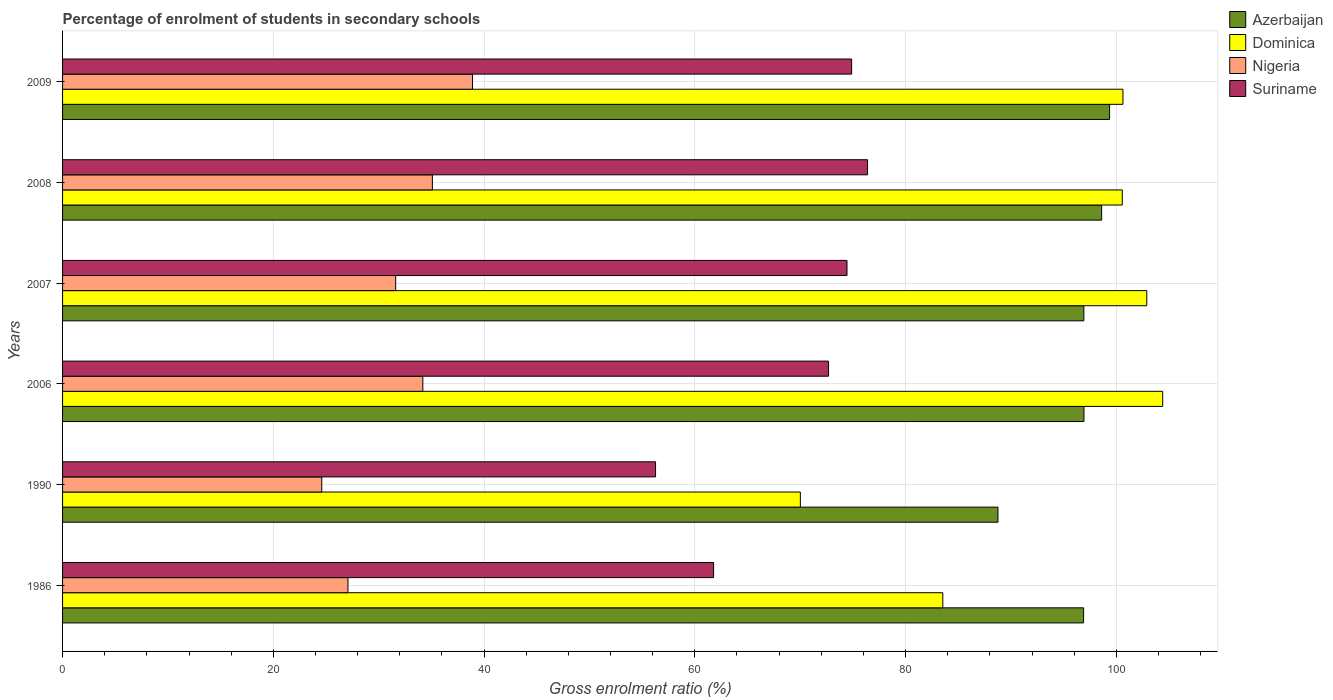How many groups of bars are there?
Offer a very short reply. 6. Are the number of bars on each tick of the Y-axis equal?
Offer a very short reply. Yes. How many bars are there on the 3rd tick from the top?
Offer a terse response. 4. What is the label of the 2nd group of bars from the top?
Your response must be concise. 2008. In how many cases, is the number of bars for a given year not equal to the number of legend labels?
Your answer should be very brief. 0. What is the percentage of students enrolled in secondary schools in Nigeria in 1986?
Provide a succinct answer. 27.08. Across all years, what is the maximum percentage of students enrolled in secondary schools in Azerbaijan?
Provide a short and direct response. 99.36. Across all years, what is the minimum percentage of students enrolled in secondary schools in Suriname?
Give a very brief answer. 56.27. What is the total percentage of students enrolled in secondary schools in Dominica in the graph?
Offer a very short reply. 562.02. What is the difference between the percentage of students enrolled in secondary schools in Suriname in 2008 and that in 2009?
Offer a very short reply. 1.51. What is the difference between the percentage of students enrolled in secondary schools in Azerbaijan in 1990 and the percentage of students enrolled in secondary schools in Nigeria in 2007?
Your response must be concise. 57.15. What is the average percentage of students enrolled in secondary schools in Azerbaijan per year?
Your answer should be very brief. 96.24. In the year 2009, what is the difference between the percentage of students enrolled in secondary schools in Nigeria and percentage of students enrolled in secondary schools in Suriname?
Provide a succinct answer. -35.98. What is the ratio of the percentage of students enrolled in secondary schools in Nigeria in 2007 to that in 2008?
Ensure brevity in your answer.  0.9. Is the percentage of students enrolled in secondary schools in Azerbaijan in 1990 less than that in 2007?
Your answer should be very brief. Yes. Is the difference between the percentage of students enrolled in secondary schools in Nigeria in 2006 and 2007 greater than the difference between the percentage of students enrolled in secondary schools in Suriname in 2006 and 2007?
Your response must be concise. Yes. What is the difference between the highest and the second highest percentage of students enrolled in secondary schools in Azerbaijan?
Give a very brief answer. 0.75. What is the difference between the highest and the lowest percentage of students enrolled in secondary schools in Azerbaijan?
Give a very brief answer. 10.59. In how many years, is the percentage of students enrolled in secondary schools in Nigeria greater than the average percentage of students enrolled in secondary schools in Nigeria taken over all years?
Your response must be concise. 3. What does the 3rd bar from the top in 2008 represents?
Offer a very short reply. Dominica. What does the 3rd bar from the bottom in 2006 represents?
Your answer should be compact. Nigeria. Is it the case that in every year, the sum of the percentage of students enrolled in secondary schools in Azerbaijan and percentage of students enrolled in secondary schools in Nigeria is greater than the percentage of students enrolled in secondary schools in Dominica?
Your answer should be compact. Yes. How many bars are there?
Provide a short and direct response. 24. Are all the bars in the graph horizontal?
Provide a short and direct response. Yes. How many years are there in the graph?
Ensure brevity in your answer.  6. What is the difference between two consecutive major ticks on the X-axis?
Keep it short and to the point. 20. Does the graph contain any zero values?
Provide a short and direct response. No. Does the graph contain grids?
Give a very brief answer. Yes. What is the title of the graph?
Your answer should be compact. Percentage of enrolment of students in secondary schools. Does "Chile" appear as one of the legend labels in the graph?
Offer a very short reply. No. What is the Gross enrolment ratio (%) in Azerbaijan in 1986?
Give a very brief answer. 96.89. What is the Gross enrolment ratio (%) in Dominica in 1986?
Provide a short and direct response. 83.53. What is the Gross enrolment ratio (%) in Nigeria in 1986?
Offer a terse response. 27.08. What is the Gross enrolment ratio (%) in Suriname in 1986?
Provide a short and direct response. 61.78. What is the Gross enrolment ratio (%) of Azerbaijan in 1990?
Keep it short and to the point. 88.76. What is the Gross enrolment ratio (%) in Dominica in 1990?
Your answer should be compact. 70.01. What is the Gross enrolment ratio (%) of Nigeria in 1990?
Offer a very short reply. 24.6. What is the Gross enrolment ratio (%) of Suriname in 1990?
Your answer should be very brief. 56.27. What is the Gross enrolment ratio (%) of Azerbaijan in 2006?
Your response must be concise. 96.93. What is the Gross enrolment ratio (%) in Dominica in 2006?
Your answer should be very brief. 104.4. What is the Gross enrolment ratio (%) in Nigeria in 2006?
Offer a very short reply. 34.19. What is the Gross enrolment ratio (%) of Suriname in 2006?
Provide a short and direct response. 72.69. What is the Gross enrolment ratio (%) in Azerbaijan in 2007?
Keep it short and to the point. 96.92. What is the Gross enrolment ratio (%) of Dominica in 2007?
Ensure brevity in your answer.  102.89. What is the Gross enrolment ratio (%) of Nigeria in 2007?
Provide a short and direct response. 31.61. What is the Gross enrolment ratio (%) in Suriname in 2007?
Your response must be concise. 74.44. What is the Gross enrolment ratio (%) in Azerbaijan in 2008?
Offer a very short reply. 98.61. What is the Gross enrolment ratio (%) in Dominica in 2008?
Give a very brief answer. 100.56. What is the Gross enrolment ratio (%) in Nigeria in 2008?
Provide a succinct answer. 35.09. What is the Gross enrolment ratio (%) of Suriname in 2008?
Provide a short and direct response. 76.39. What is the Gross enrolment ratio (%) of Azerbaijan in 2009?
Your response must be concise. 99.36. What is the Gross enrolment ratio (%) in Dominica in 2009?
Make the answer very short. 100.63. What is the Gross enrolment ratio (%) in Nigeria in 2009?
Ensure brevity in your answer.  38.9. What is the Gross enrolment ratio (%) of Suriname in 2009?
Give a very brief answer. 74.88. Across all years, what is the maximum Gross enrolment ratio (%) in Azerbaijan?
Offer a very short reply. 99.36. Across all years, what is the maximum Gross enrolment ratio (%) of Dominica?
Provide a succinct answer. 104.4. Across all years, what is the maximum Gross enrolment ratio (%) in Nigeria?
Your answer should be compact. 38.9. Across all years, what is the maximum Gross enrolment ratio (%) in Suriname?
Offer a very short reply. 76.39. Across all years, what is the minimum Gross enrolment ratio (%) in Azerbaijan?
Make the answer very short. 88.76. Across all years, what is the minimum Gross enrolment ratio (%) in Dominica?
Your answer should be very brief. 70.01. Across all years, what is the minimum Gross enrolment ratio (%) in Nigeria?
Give a very brief answer. 24.6. Across all years, what is the minimum Gross enrolment ratio (%) of Suriname?
Offer a very short reply. 56.27. What is the total Gross enrolment ratio (%) of Azerbaijan in the graph?
Keep it short and to the point. 577.46. What is the total Gross enrolment ratio (%) in Dominica in the graph?
Ensure brevity in your answer.  562.02. What is the total Gross enrolment ratio (%) of Nigeria in the graph?
Provide a short and direct response. 191.47. What is the total Gross enrolment ratio (%) in Suriname in the graph?
Give a very brief answer. 416.45. What is the difference between the Gross enrolment ratio (%) of Azerbaijan in 1986 and that in 1990?
Your response must be concise. 8.13. What is the difference between the Gross enrolment ratio (%) in Dominica in 1986 and that in 1990?
Provide a succinct answer. 13.52. What is the difference between the Gross enrolment ratio (%) of Nigeria in 1986 and that in 1990?
Provide a short and direct response. 2.49. What is the difference between the Gross enrolment ratio (%) of Suriname in 1986 and that in 1990?
Offer a terse response. 5.51. What is the difference between the Gross enrolment ratio (%) of Azerbaijan in 1986 and that in 2006?
Keep it short and to the point. -0.03. What is the difference between the Gross enrolment ratio (%) of Dominica in 1986 and that in 2006?
Keep it short and to the point. -20.87. What is the difference between the Gross enrolment ratio (%) in Nigeria in 1986 and that in 2006?
Provide a short and direct response. -7.11. What is the difference between the Gross enrolment ratio (%) of Suriname in 1986 and that in 2006?
Offer a terse response. -10.91. What is the difference between the Gross enrolment ratio (%) of Azerbaijan in 1986 and that in 2007?
Give a very brief answer. -0.02. What is the difference between the Gross enrolment ratio (%) in Dominica in 1986 and that in 2007?
Offer a terse response. -19.36. What is the difference between the Gross enrolment ratio (%) in Nigeria in 1986 and that in 2007?
Give a very brief answer. -4.53. What is the difference between the Gross enrolment ratio (%) in Suriname in 1986 and that in 2007?
Ensure brevity in your answer.  -12.66. What is the difference between the Gross enrolment ratio (%) of Azerbaijan in 1986 and that in 2008?
Offer a very short reply. -1.71. What is the difference between the Gross enrolment ratio (%) of Dominica in 1986 and that in 2008?
Ensure brevity in your answer.  -17.03. What is the difference between the Gross enrolment ratio (%) of Nigeria in 1986 and that in 2008?
Your response must be concise. -8.01. What is the difference between the Gross enrolment ratio (%) of Suriname in 1986 and that in 2008?
Provide a short and direct response. -14.61. What is the difference between the Gross enrolment ratio (%) in Azerbaijan in 1986 and that in 2009?
Provide a short and direct response. -2.46. What is the difference between the Gross enrolment ratio (%) of Dominica in 1986 and that in 2009?
Your answer should be compact. -17.1. What is the difference between the Gross enrolment ratio (%) of Nigeria in 1986 and that in 2009?
Make the answer very short. -11.82. What is the difference between the Gross enrolment ratio (%) in Suriname in 1986 and that in 2009?
Your response must be concise. -13.1. What is the difference between the Gross enrolment ratio (%) in Azerbaijan in 1990 and that in 2006?
Give a very brief answer. -8.16. What is the difference between the Gross enrolment ratio (%) of Dominica in 1990 and that in 2006?
Make the answer very short. -34.39. What is the difference between the Gross enrolment ratio (%) of Nigeria in 1990 and that in 2006?
Keep it short and to the point. -9.59. What is the difference between the Gross enrolment ratio (%) in Suriname in 1990 and that in 2006?
Your answer should be compact. -16.42. What is the difference between the Gross enrolment ratio (%) of Azerbaijan in 1990 and that in 2007?
Give a very brief answer. -8.15. What is the difference between the Gross enrolment ratio (%) in Dominica in 1990 and that in 2007?
Make the answer very short. -32.87. What is the difference between the Gross enrolment ratio (%) in Nigeria in 1990 and that in 2007?
Your answer should be compact. -7.01. What is the difference between the Gross enrolment ratio (%) in Suriname in 1990 and that in 2007?
Make the answer very short. -18.17. What is the difference between the Gross enrolment ratio (%) in Azerbaijan in 1990 and that in 2008?
Provide a short and direct response. -9.84. What is the difference between the Gross enrolment ratio (%) in Dominica in 1990 and that in 2008?
Your response must be concise. -30.55. What is the difference between the Gross enrolment ratio (%) of Nigeria in 1990 and that in 2008?
Give a very brief answer. -10.5. What is the difference between the Gross enrolment ratio (%) of Suriname in 1990 and that in 2008?
Give a very brief answer. -20.12. What is the difference between the Gross enrolment ratio (%) in Azerbaijan in 1990 and that in 2009?
Offer a very short reply. -10.59. What is the difference between the Gross enrolment ratio (%) of Dominica in 1990 and that in 2009?
Keep it short and to the point. -30.61. What is the difference between the Gross enrolment ratio (%) in Nigeria in 1990 and that in 2009?
Give a very brief answer. -14.31. What is the difference between the Gross enrolment ratio (%) in Suriname in 1990 and that in 2009?
Ensure brevity in your answer.  -18.61. What is the difference between the Gross enrolment ratio (%) in Azerbaijan in 2006 and that in 2007?
Keep it short and to the point. 0.01. What is the difference between the Gross enrolment ratio (%) in Dominica in 2006 and that in 2007?
Your answer should be compact. 1.51. What is the difference between the Gross enrolment ratio (%) in Nigeria in 2006 and that in 2007?
Provide a short and direct response. 2.58. What is the difference between the Gross enrolment ratio (%) in Suriname in 2006 and that in 2007?
Your response must be concise. -1.75. What is the difference between the Gross enrolment ratio (%) of Azerbaijan in 2006 and that in 2008?
Your response must be concise. -1.68. What is the difference between the Gross enrolment ratio (%) in Dominica in 2006 and that in 2008?
Provide a short and direct response. 3.84. What is the difference between the Gross enrolment ratio (%) of Nigeria in 2006 and that in 2008?
Make the answer very short. -0.91. What is the difference between the Gross enrolment ratio (%) in Suriname in 2006 and that in 2008?
Provide a short and direct response. -3.7. What is the difference between the Gross enrolment ratio (%) of Azerbaijan in 2006 and that in 2009?
Keep it short and to the point. -2.43. What is the difference between the Gross enrolment ratio (%) in Dominica in 2006 and that in 2009?
Provide a succinct answer. 3.77. What is the difference between the Gross enrolment ratio (%) in Nigeria in 2006 and that in 2009?
Keep it short and to the point. -4.71. What is the difference between the Gross enrolment ratio (%) in Suriname in 2006 and that in 2009?
Your answer should be compact. -2.19. What is the difference between the Gross enrolment ratio (%) of Azerbaijan in 2007 and that in 2008?
Your response must be concise. -1.69. What is the difference between the Gross enrolment ratio (%) in Dominica in 2007 and that in 2008?
Offer a very short reply. 2.32. What is the difference between the Gross enrolment ratio (%) in Nigeria in 2007 and that in 2008?
Provide a succinct answer. -3.48. What is the difference between the Gross enrolment ratio (%) of Suriname in 2007 and that in 2008?
Your response must be concise. -1.95. What is the difference between the Gross enrolment ratio (%) of Azerbaijan in 2007 and that in 2009?
Offer a terse response. -2.44. What is the difference between the Gross enrolment ratio (%) in Dominica in 2007 and that in 2009?
Offer a very short reply. 2.26. What is the difference between the Gross enrolment ratio (%) in Nigeria in 2007 and that in 2009?
Keep it short and to the point. -7.29. What is the difference between the Gross enrolment ratio (%) in Suriname in 2007 and that in 2009?
Offer a terse response. -0.44. What is the difference between the Gross enrolment ratio (%) in Azerbaijan in 2008 and that in 2009?
Offer a terse response. -0.75. What is the difference between the Gross enrolment ratio (%) in Dominica in 2008 and that in 2009?
Offer a very short reply. -0.06. What is the difference between the Gross enrolment ratio (%) in Nigeria in 2008 and that in 2009?
Provide a short and direct response. -3.81. What is the difference between the Gross enrolment ratio (%) in Suriname in 2008 and that in 2009?
Make the answer very short. 1.51. What is the difference between the Gross enrolment ratio (%) of Azerbaijan in 1986 and the Gross enrolment ratio (%) of Dominica in 1990?
Your answer should be very brief. 26.88. What is the difference between the Gross enrolment ratio (%) in Azerbaijan in 1986 and the Gross enrolment ratio (%) in Nigeria in 1990?
Provide a succinct answer. 72.3. What is the difference between the Gross enrolment ratio (%) in Azerbaijan in 1986 and the Gross enrolment ratio (%) in Suriname in 1990?
Your answer should be very brief. 40.62. What is the difference between the Gross enrolment ratio (%) in Dominica in 1986 and the Gross enrolment ratio (%) in Nigeria in 1990?
Keep it short and to the point. 58.94. What is the difference between the Gross enrolment ratio (%) in Dominica in 1986 and the Gross enrolment ratio (%) in Suriname in 1990?
Give a very brief answer. 27.26. What is the difference between the Gross enrolment ratio (%) of Nigeria in 1986 and the Gross enrolment ratio (%) of Suriname in 1990?
Your answer should be compact. -29.19. What is the difference between the Gross enrolment ratio (%) in Azerbaijan in 1986 and the Gross enrolment ratio (%) in Dominica in 2006?
Your answer should be compact. -7.51. What is the difference between the Gross enrolment ratio (%) in Azerbaijan in 1986 and the Gross enrolment ratio (%) in Nigeria in 2006?
Give a very brief answer. 62.71. What is the difference between the Gross enrolment ratio (%) of Azerbaijan in 1986 and the Gross enrolment ratio (%) of Suriname in 2006?
Keep it short and to the point. 24.2. What is the difference between the Gross enrolment ratio (%) in Dominica in 1986 and the Gross enrolment ratio (%) in Nigeria in 2006?
Offer a very short reply. 49.34. What is the difference between the Gross enrolment ratio (%) of Dominica in 1986 and the Gross enrolment ratio (%) of Suriname in 2006?
Ensure brevity in your answer.  10.84. What is the difference between the Gross enrolment ratio (%) of Nigeria in 1986 and the Gross enrolment ratio (%) of Suriname in 2006?
Provide a succinct answer. -45.61. What is the difference between the Gross enrolment ratio (%) in Azerbaijan in 1986 and the Gross enrolment ratio (%) in Dominica in 2007?
Provide a succinct answer. -5.99. What is the difference between the Gross enrolment ratio (%) in Azerbaijan in 1986 and the Gross enrolment ratio (%) in Nigeria in 2007?
Make the answer very short. 65.28. What is the difference between the Gross enrolment ratio (%) of Azerbaijan in 1986 and the Gross enrolment ratio (%) of Suriname in 2007?
Offer a very short reply. 22.45. What is the difference between the Gross enrolment ratio (%) in Dominica in 1986 and the Gross enrolment ratio (%) in Nigeria in 2007?
Ensure brevity in your answer.  51.92. What is the difference between the Gross enrolment ratio (%) in Dominica in 1986 and the Gross enrolment ratio (%) in Suriname in 2007?
Provide a succinct answer. 9.09. What is the difference between the Gross enrolment ratio (%) in Nigeria in 1986 and the Gross enrolment ratio (%) in Suriname in 2007?
Your answer should be very brief. -47.36. What is the difference between the Gross enrolment ratio (%) of Azerbaijan in 1986 and the Gross enrolment ratio (%) of Dominica in 2008?
Your answer should be compact. -3.67. What is the difference between the Gross enrolment ratio (%) of Azerbaijan in 1986 and the Gross enrolment ratio (%) of Nigeria in 2008?
Your response must be concise. 61.8. What is the difference between the Gross enrolment ratio (%) of Azerbaijan in 1986 and the Gross enrolment ratio (%) of Suriname in 2008?
Provide a short and direct response. 20.5. What is the difference between the Gross enrolment ratio (%) of Dominica in 1986 and the Gross enrolment ratio (%) of Nigeria in 2008?
Keep it short and to the point. 48.44. What is the difference between the Gross enrolment ratio (%) in Dominica in 1986 and the Gross enrolment ratio (%) in Suriname in 2008?
Your answer should be very brief. 7.14. What is the difference between the Gross enrolment ratio (%) of Nigeria in 1986 and the Gross enrolment ratio (%) of Suriname in 2008?
Give a very brief answer. -49.31. What is the difference between the Gross enrolment ratio (%) in Azerbaijan in 1986 and the Gross enrolment ratio (%) in Dominica in 2009?
Your answer should be compact. -3.73. What is the difference between the Gross enrolment ratio (%) in Azerbaijan in 1986 and the Gross enrolment ratio (%) in Nigeria in 2009?
Offer a terse response. 57.99. What is the difference between the Gross enrolment ratio (%) in Azerbaijan in 1986 and the Gross enrolment ratio (%) in Suriname in 2009?
Provide a short and direct response. 22.01. What is the difference between the Gross enrolment ratio (%) of Dominica in 1986 and the Gross enrolment ratio (%) of Nigeria in 2009?
Provide a succinct answer. 44.63. What is the difference between the Gross enrolment ratio (%) of Dominica in 1986 and the Gross enrolment ratio (%) of Suriname in 2009?
Your response must be concise. 8.65. What is the difference between the Gross enrolment ratio (%) in Nigeria in 1986 and the Gross enrolment ratio (%) in Suriname in 2009?
Your answer should be very brief. -47.8. What is the difference between the Gross enrolment ratio (%) of Azerbaijan in 1990 and the Gross enrolment ratio (%) of Dominica in 2006?
Your answer should be compact. -15.63. What is the difference between the Gross enrolment ratio (%) in Azerbaijan in 1990 and the Gross enrolment ratio (%) in Nigeria in 2006?
Make the answer very short. 54.58. What is the difference between the Gross enrolment ratio (%) in Azerbaijan in 1990 and the Gross enrolment ratio (%) in Suriname in 2006?
Your response must be concise. 16.08. What is the difference between the Gross enrolment ratio (%) in Dominica in 1990 and the Gross enrolment ratio (%) in Nigeria in 2006?
Provide a short and direct response. 35.83. What is the difference between the Gross enrolment ratio (%) of Dominica in 1990 and the Gross enrolment ratio (%) of Suriname in 2006?
Make the answer very short. -2.67. What is the difference between the Gross enrolment ratio (%) of Nigeria in 1990 and the Gross enrolment ratio (%) of Suriname in 2006?
Your response must be concise. -48.09. What is the difference between the Gross enrolment ratio (%) in Azerbaijan in 1990 and the Gross enrolment ratio (%) in Dominica in 2007?
Provide a succinct answer. -14.12. What is the difference between the Gross enrolment ratio (%) in Azerbaijan in 1990 and the Gross enrolment ratio (%) in Nigeria in 2007?
Offer a terse response. 57.15. What is the difference between the Gross enrolment ratio (%) of Azerbaijan in 1990 and the Gross enrolment ratio (%) of Suriname in 2007?
Make the answer very short. 14.32. What is the difference between the Gross enrolment ratio (%) of Dominica in 1990 and the Gross enrolment ratio (%) of Nigeria in 2007?
Ensure brevity in your answer.  38.4. What is the difference between the Gross enrolment ratio (%) of Dominica in 1990 and the Gross enrolment ratio (%) of Suriname in 2007?
Offer a terse response. -4.43. What is the difference between the Gross enrolment ratio (%) of Nigeria in 1990 and the Gross enrolment ratio (%) of Suriname in 2007?
Your answer should be compact. -49.84. What is the difference between the Gross enrolment ratio (%) of Azerbaijan in 1990 and the Gross enrolment ratio (%) of Dominica in 2008?
Ensure brevity in your answer.  -11.8. What is the difference between the Gross enrolment ratio (%) of Azerbaijan in 1990 and the Gross enrolment ratio (%) of Nigeria in 2008?
Offer a very short reply. 53.67. What is the difference between the Gross enrolment ratio (%) of Azerbaijan in 1990 and the Gross enrolment ratio (%) of Suriname in 2008?
Your answer should be compact. 12.37. What is the difference between the Gross enrolment ratio (%) of Dominica in 1990 and the Gross enrolment ratio (%) of Nigeria in 2008?
Your response must be concise. 34.92. What is the difference between the Gross enrolment ratio (%) in Dominica in 1990 and the Gross enrolment ratio (%) in Suriname in 2008?
Your answer should be very brief. -6.38. What is the difference between the Gross enrolment ratio (%) of Nigeria in 1990 and the Gross enrolment ratio (%) of Suriname in 2008?
Your response must be concise. -51.8. What is the difference between the Gross enrolment ratio (%) in Azerbaijan in 1990 and the Gross enrolment ratio (%) in Dominica in 2009?
Provide a succinct answer. -11.86. What is the difference between the Gross enrolment ratio (%) in Azerbaijan in 1990 and the Gross enrolment ratio (%) in Nigeria in 2009?
Provide a short and direct response. 49.86. What is the difference between the Gross enrolment ratio (%) of Azerbaijan in 1990 and the Gross enrolment ratio (%) of Suriname in 2009?
Your answer should be compact. 13.88. What is the difference between the Gross enrolment ratio (%) of Dominica in 1990 and the Gross enrolment ratio (%) of Nigeria in 2009?
Your answer should be very brief. 31.11. What is the difference between the Gross enrolment ratio (%) of Dominica in 1990 and the Gross enrolment ratio (%) of Suriname in 2009?
Keep it short and to the point. -4.87. What is the difference between the Gross enrolment ratio (%) of Nigeria in 1990 and the Gross enrolment ratio (%) of Suriname in 2009?
Ensure brevity in your answer.  -50.28. What is the difference between the Gross enrolment ratio (%) in Azerbaijan in 2006 and the Gross enrolment ratio (%) in Dominica in 2007?
Ensure brevity in your answer.  -5.96. What is the difference between the Gross enrolment ratio (%) of Azerbaijan in 2006 and the Gross enrolment ratio (%) of Nigeria in 2007?
Ensure brevity in your answer.  65.32. What is the difference between the Gross enrolment ratio (%) of Azerbaijan in 2006 and the Gross enrolment ratio (%) of Suriname in 2007?
Your answer should be compact. 22.49. What is the difference between the Gross enrolment ratio (%) in Dominica in 2006 and the Gross enrolment ratio (%) in Nigeria in 2007?
Keep it short and to the point. 72.79. What is the difference between the Gross enrolment ratio (%) of Dominica in 2006 and the Gross enrolment ratio (%) of Suriname in 2007?
Ensure brevity in your answer.  29.96. What is the difference between the Gross enrolment ratio (%) of Nigeria in 2006 and the Gross enrolment ratio (%) of Suriname in 2007?
Make the answer very short. -40.25. What is the difference between the Gross enrolment ratio (%) in Azerbaijan in 2006 and the Gross enrolment ratio (%) in Dominica in 2008?
Make the answer very short. -3.64. What is the difference between the Gross enrolment ratio (%) in Azerbaijan in 2006 and the Gross enrolment ratio (%) in Nigeria in 2008?
Your answer should be compact. 61.83. What is the difference between the Gross enrolment ratio (%) in Azerbaijan in 2006 and the Gross enrolment ratio (%) in Suriname in 2008?
Provide a succinct answer. 20.53. What is the difference between the Gross enrolment ratio (%) in Dominica in 2006 and the Gross enrolment ratio (%) in Nigeria in 2008?
Your response must be concise. 69.31. What is the difference between the Gross enrolment ratio (%) of Dominica in 2006 and the Gross enrolment ratio (%) of Suriname in 2008?
Give a very brief answer. 28.01. What is the difference between the Gross enrolment ratio (%) in Nigeria in 2006 and the Gross enrolment ratio (%) in Suriname in 2008?
Provide a succinct answer. -42.2. What is the difference between the Gross enrolment ratio (%) in Azerbaijan in 2006 and the Gross enrolment ratio (%) in Dominica in 2009?
Provide a short and direct response. -3.7. What is the difference between the Gross enrolment ratio (%) of Azerbaijan in 2006 and the Gross enrolment ratio (%) of Nigeria in 2009?
Provide a short and direct response. 58.02. What is the difference between the Gross enrolment ratio (%) of Azerbaijan in 2006 and the Gross enrolment ratio (%) of Suriname in 2009?
Ensure brevity in your answer.  22.05. What is the difference between the Gross enrolment ratio (%) of Dominica in 2006 and the Gross enrolment ratio (%) of Nigeria in 2009?
Your answer should be compact. 65.5. What is the difference between the Gross enrolment ratio (%) in Dominica in 2006 and the Gross enrolment ratio (%) in Suriname in 2009?
Your response must be concise. 29.52. What is the difference between the Gross enrolment ratio (%) of Nigeria in 2006 and the Gross enrolment ratio (%) of Suriname in 2009?
Keep it short and to the point. -40.69. What is the difference between the Gross enrolment ratio (%) in Azerbaijan in 2007 and the Gross enrolment ratio (%) in Dominica in 2008?
Offer a terse response. -3.65. What is the difference between the Gross enrolment ratio (%) in Azerbaijan in 2007 and the Gross enrolment ratio (%) in Nigeria in 2008?
Offer a very short reply. 61.82. What is the difference between the Gross enrolment ratio (%) of Azerbaijan in 2007 and the Gross enrolment ratio (%) of Suriname in 2008?
Make the answer very short. 20.53. What is the difference between the Gross enrolment ratio (%) in Dominica in 2007 and the Gross enrolment ratio (%) in Nigeria in 2008?
Your answer should be compact. 67.79. What is the difference between the Gross enrolment ratio (%) of Dominica in 2007 and the Gross enrolment ratio (%) of Suriname in 2008?
Your answer should be very brief. 26.5. What is the difference between the Gross enrolment ratio (%) of Nigeria in 2007 and the Gross enrolment ratio (%) of Suriname in 2008?
Offer a very short reply. -44.78. What is the difference between the Gross enrolment ratio (%) in Azerbaijan in 2007 and the Gross enrolment ratio (%) in Dominica in 2009?
Offer a very short reply. -3.71. What is the difference between the Gross enrolment ratio (%) of Azerbaijan in 2007 and the Gross enrolment ratio (%) of Nigeria in 2009?
Your answer should be compact. 58.02. What is the difference between the Gross enrolment ratio (%) in Azerbaijan in 2007 and the Gross enrolment ratio (%) in Suriname in 2009?
Provide a succinct answer. 22.04. What is the difference between the Gross enrolment ratio (%) of Dominica in 2007 and the Gross enrolment ratio (%) of Nigeria in 2009?
Ensure brevity in your answer.  63.99. What is the difference between the Gross enrolment ratio (%) in Dominica in 2007 and the Gross enrolment ratio (%) in Suriname in 2009?
Give a very brief answer. 28.01. What is the difference between the Gross enrolment ratio (%) of Nigeria in 2007 and the Gross enrolment ratio (%) of Suriname in 2009?
Provide a short and direct response. -43.27. What is the difference between the Gross enrolment ratio (%) in Azerbaijan in 2008 and the Gross enrolment ratio (%) in Dominica in 2009?
Keep it short and to the point. -2.02. What is the difference between the Gross enrolment ratio (%) of Azerbaijan in 2008 and the Gross enrolment ratio (%) of Nigeria in 2009?
Give a very brief answer. 59.7. What is the difference between the Gross enrolment ratio (%) in Azerbaijan in 2008 and the Gross enrolment ratio (%) in Suriname in 2009?
Your answer should be compact. 23.73. What is the difference between the Gross enrolment ratio (%) of Dominica in 2008 and the Gross enrolment ratio (%) of Nigeria in 2009?
Offer a very short reply. 61.66. What is the difference between the Gross enrolment ratio (%) in Dominica in 2008 and the Gross enrolment ratio (%) in Suriname in 2009?
Give a very brief answer. 25.68. What is the difference between the Gross enrolment ratio (%) in Nigeria in 2008 and the Gross enrolment ratio (%) in Suriname in 2009?
Provide a succinct answer. -39.79. What is the average Gross enrolment ratio (%) of Azerbaijan per year?
Your answer should be very brief. 96.24. What is the average Gross enrolment ratio (%) in Dominica per year?
Keep it short and to the point. 93.67. What is the average Gross enrolment ratio (%) in Nigeria per year?
Offer a very short reply. 31.91. What is the average Gross enrolment ratio (%) in Suriname per year?
Offer a very short reply. 69.41. In the year 1986, what is the difference between the Gross enrolment ratio (%) of Azerbaijan and Gross enrolment ratio (%) of Dominica?
Your response must be concise. 13.36. In the year 1986, what is the difference between the Gross enrolment ratio (%) in Azerbaijan and Gross enrolment ratio (%) in Nigeria?
Make the answer very short. 69.81. In the year 1986, what is the difference between the Gross enrolment ratio (%) in Azerbaijan and Gross enrolment ratio (%) in Suriname?
Give a very brief answer. 35.11. In the year 1986, what is the difference between the Gross enrolment ratio (%) in Dominica and Gross enrolment ratio (%) in Nigeria?
Offer a very short reply. 56.45. In the year 1986, what is the difference between the Gross enrolment ratio (%) in Dominica and Gross enrolment ratio (%) in Suriname?
Provide a succinct answer. 21.75. In the year 1986, what is the difference between the Gross enrolment ratio (%) in Nigeria and Gross enrolment ratio (%) in Suriname?
Provide a succinct answer. -34.7. In the year 1990, what is the difference between the Gross enrolment ratio (%) in Azerbaijan and Gross enrolment ratio (%) in Dominica?
Ensure brevity in your answer.  18.75. In the year 1990, what is the difference between the Gross enrolment ratio (%) in Azerbaijan and Gross enrolment ratio (%) in Nigeria?
Your answer should be compact. 64.17. In the year 1990, what is the difference between the Gross enrolment ratio (%) of Azerbaijan and Gross enrolment ratio (%) of Suriname?
Your answer should be very brief. 32.49. In the year 1990, what is the difference between the Gross enrolment ratio (%) in Dominica and Gross enrolment ratio (%) in Nigeria?
Make the answer very short. 45.42. In the year 1990, what is the difference between the Gross enrolment ratio (%) in Dominica and Gross enrolment ratio (%) in Suriname?
Your response must be concise. 13.74. In the year 1990, what is the difference between the Gross enrolment ratio (%) in Nigeria and Gross enrolment ratio (%) in Suriname?
Your response must be concise. -31.68. In the year 2006, what is the difference between the Gross enrolment ratio (%) in Azerbaijan and Gross enrolment ratio (%) in Dominica?
Provide a short and direct response. -7.47. In the year 2006, what is the difference between the Gross enrolment ratio (%) in Azerbaijan and Gross enrolment ratio (%) in Nigeria?
Provide a succinct answer. 62.74. In the year 2006, what is the difference between the Gross enrolment ratio (%) in Azerbaijan and Gross enrolment ratio (%) in Suriname?
Make the answer very short. 24.24. In the year 2006, what is the difference between the Gross enrolment ratio (%) of Dominica and Gross enrolment ratio (%) of Nigeria?
Ensure brevity in your answer.  70.21. In the year 2006, what is the difference between the Gross enrolment ratio (%) in Dominica and Gross enrolment ratio (%) in Suriname?
Offer a very short reply. 31.71. In the year 2006, what is the difference between the Gross enrolment ratio (%) in Nigeria and Gross enrolment ratio (%) in Suriname?
Offer a very short reply. -38.5. In the year 2007, what is the difference between the Gross enrolment ratio (%) of Azerbaijan and Gross enrolment ratio (%) of Dominica?
Offer a terse response. -5.97. In the year 2007, what is the difference between the Gross enrolment ratio (%) of Azerbaijan and Gross enrolment ratio (%) of Nigeria?
Provide a succinct answer. 65.31. In the year 2007, what is the difference between the Gross enrolment ratio (%) of Azerbaijan and Gross enrolment ratio (%) of Suriname?
Provide a succinct answer. 22.48. In the year 2007, what is the difference between the Gross enrolment ratio (%) in Dominica and Gross enrolment ratio (%) in Nigeria?
Provide a short and direct response. 71.28. In the year 2007, what is the difference between the Gross enrolment ratio (%) in Dominica and Gross enrolment ratio (%) in Suriname?
Provide a succinct answer. 28.45. In the year 2007, what is the difference between the Gross enrolment ratio (%) of Nigeria and Gross enrolment ratio (%) of Suriname?
Offer a terse response. -42.83. In the year 2008, what is the difference between the Gross enrolment ratio (%) of Azerbaijan and Gross enrolment ratio (%) of Dominica?
Your answer should be compact. -1.96. In the year 2008, what is the difference between the Gross enrolment ratio (%) in Azerbaijan and Gross enrolment ratio (%) in Nigeria?
Your response must be concise. 63.51. In the year 2008, what is the difference between the Gross enrolment ratio (%) of Azerbaijan and Gross enrolment ratio (%) of Suriname?
Provide a succinct answer. 22.21. In the year 2008, what is the difference between the Gross enrolment ratio (%) of Dominica and Gross enrolment ratio (%) of Nigeria?
Make the answer very short. 65.47. In the year 2008, what is the difference between the Gross enrolment ratio (%) in Dominica and Gross enrolment ratio (%) in Suriname?
Ensure brevity in your answer.  24.17. In the year 2008, what is the difference between the Gross enrolment ratio (%) in Nigeria and Gross enrolment ratio (%) in Suriname?
Offer a very short reply. -41.3. In the year 2009, what is the difference between the Gross enrolment ratio (%) of Azerbaijan and Gross enrolment ratio (%) of Dominica?
Your answer should be compact. -1.27. In the year 2009, what is the difference between the Gross enrolment ratio (%) of Azerbaijan and Gross enrolment ratio (%) of Nigeria?
Offer a very short reply. 60.46. In the year 2009, what is the difference between the Gross enrolment ratio (%) of Azerbaijan and Gross enrolment ratio (%) of Suriname?
Your answer should be very brief. 24.48. In the year 2009, what is the difference between the Gross enrolment ratio (%) of Dominica and Gross enrolment ratio (%) of Nigeria?
Your answer should be very brief. 61.73. In the year 2009, what is the difference between the Gross enrolment ratio (%) of Dominica and Gross enrolment ratio (%) of Suriname?
Your answer should be compact. 25.75. In the year 2009, what is the difference between the Gross enrolment ratio (%) of Nigeria and Gross enrolment ratio (%) of Suriname?
Your response must be concise. -35.98. What is the ratio of the Gross enrolment ratio (%) in Azerbaijan in 1986 to that in 1990?
Offer a terse response. 1.09. What is the ratio of the Gross enrolment ratio (%) of Dominica in 1986 to that in 1990?
Your answer should be very brief. 1.19. What is the ratio of the Gross enrolment ratio (%) of Nigeria in 1986 to that in 1990?
Your answer should be very brief. 1.1. What is the ratio of the Gross enrolment ratio (%) in Suriname in 1986 to that in 1990?
Provide a succinct answer. 1.1. What is the ratio of the Gross enrolment ratio (%) of Dominica in 1986 to that in 2006?
Provide a succinct answer. 0.8. What is the ratio of the Gross enrolment ratio (%) in Nigeria in 1986 to that in 2006?
Give a very brief answer. 0.79. What is the ratio of the Gross enrolment ratio (%) of Suriname in 1986 to that in 2006?
Make the answer very short. 0.85. What is the ratio of the Gross enrolment ratio (%) of Azerbaijan in 1986 to that in 2007?
Provide a short and direct response. 1. What is the ratio of the Gross enrolment ratio (%) in Dominica in 1986 to that in 2007?
Ensure brevity in your answer.  0.81. What is the ratio of the Gross enrolment ratio (%) of Nigeria in 1986 to that in 2007?
Offer a very short reply. 0.86. What is the ratio of the Gross enrolment ratio (%) in Suriname in 1986 to that in 2007?
Offer a terse response. 0.83. What is the ratio of the Gross enrolment ratio (%) in Azerbaijan in 1986 to that in 2008?
Provide a succinct answer. 0.98. What is the ratio of the Gross enrolment ratio (%) of Dominica in 1986 to that in 2008?
Give a very brief answer. 0.83. What is the ratio of the Gross enrolment ratio (%) in Nigeria in 1986 to that in 2008?
Provide a succinct answer. 0.77. What is the ratio of the Gross enrolment ratio (%) in Suriname in 1986 to that in 2008?
Your answer should be very brief. 0.81. What is the ratio of the Gross enrolment ratio (%) of Azerbaijan in 1986 to that in 2009?
Your response must be concise. 0.98. What is the ratio of the Gross enrolment ratio (%) in Dominica in 1986 to that in 2009?
Offer a very short reply. 0.83. What is the ratio of the Gross enrolment ratio (%) of Nigeria in 1986 to that in 2009?
Your answer should be very brief. 0.7. What is the ratio of the Gross enrolment ratio (%) in Suriname in 1986 to that in 2009?
Offer a terse response. 0.83. What is the ratio of the Gross enrolment ratio (%) in Azerbaijan in 1990 to that in 2006?
Ensure brevity in your answer.  0.92. What is the ratio of the Gross enrolment ratio (%) in Dominica in 1990 to that in 2006?
Provide a short and direct response. 0.67. What is the ratio of the Gross enrolment ratio (%) in Nigeria in 1990 to that in 2006?
Offer a terse response. 0.72. What is the ratio of the Gross enrolment ratio (%) of Suriname in 1990 to that in 2006?
Provide a succinct answer. 0.77. What is the ratio of the Gross enrolment ratio (%) in Azerbaijan in 1990 to that in 2007?
Your answer should be compact. 0.92. What is the ratio of the Gross enrolment ratio (%) of Dominica in 1990 to that in 2007?
Make the answer very short. 0.68. What is the ratio of the Gross enrolment ratio (%) in Nigeria in 1990 to that in 2007?
Your response must be concise. 0.78. What is the ratio of the Gross enrolment ratio (%) of Suriname in 1990 to that in 2007?
Your answer should be compact. 0.76. What is the ratio of the Gross enrolment ratio (%) of Azerbaijan in 1990 to that in 2008?
Keep it short and to the point. 0.9. What is the ratio of the Gross enrolment ratio (%) in Dominica in 1990 to that in 2008?
Your response must be concise. 0.7. What is the ratio of the Gross enrolment ratio (%) of Nigeria in 1990 to that in 2008?
Keep it short and to the point. 0.7. What is the ratio of the Gross enrolment ratio (%) of Suriname in 1990 to that in 2008?
Ensure brevity in your answer.  0.74. What is the ratio of the Gross enrolment ratio (%) of Azerbaijan in 1990 to that in 2009?
Offer a terse response. 0.89. What is the ratio of the Gross enrolment ratio (%) of Dominica in 1990 to that in 2009?
Your answer should be very brief. 0.7. What is the ratio of the Gross enrolment ratio (%) of Nigeria in 1990 to that in 2009?
Your response must be concise. 0.63. What is the ratio of the Gross enrolment ratio (%) of Suriname in 1990 to that in 2009?
Offer a very short reply. 0.75. What is the ratio of the Gross enrolment ratio (%) in Azerbaijan in 2006 to that in 2007?
Provide a succinct answer. 1. What is the ratio of the Gross enrolment ratio (%) in Dominica in 2006 to that in 2007?
Your answer should be compact. 1.01. What is the ratio of the Gross enrolment ratio (%) in Nigeria in 2006 to that in 2007?
Give a very brief answer. 1.08. What is the ratio of the Gross enrolment ratio (%) in Suriname in 2006 to that in 2007?
Offer a very short reply. 0.98. What is the ratio of the Gross enrolment ratio (%) in Azerbaijan in 2006 to that in 2008?
Provide a succinct answer. 0.98. What is the ratio of the Gross enrolment ratio (%) of Dominica in 2006 to that in 2008?
Provide a short and direct response. 1.04. What is the ratio of the Gross enrolment ratio (%) in Nigeria in 2006 to that in 2008?
Your response must be concise. 0.97. What is the ratio of the Gross enrolment ratio (%) of Suriname in 2006 to that in 2008?
Your answer should be compact. 0.95. What is the ratio of the Gross enrolment ratio (%) of Azerbaijan in 2006 to that in 2009?
Your answer should be compact. 0.98. What is the ratio of the Gross enrolment ratio (%) of Dominica in 2006 to that in 2009?
Your answer should be compact. 1.04. What is the ratio of the Gross enrolment ratio (%) of Nigeria in 2006 to that in 2009?
Offer a terse response. 0.88. What is the ratio of the Gross enrolment ratio (%) of Suriname in 2006 to that in 2009?
Give a very brief answer. 0.97. What is the ratio of the Gross enrolment ratio (%) of Azerbaijan in 2007 to that in 2008?
Offer a very short reply. 0.98. What is the ratio of the Gross enrolment ratio (%) of Dominica in 2007 to that in 2008?
Provide a short and direct response. 1.02. What is the ratio of the Gross enrolment ratio (%) of Nigeria in 2007 to that in 2008?
Make the answer very short. 0.9. What is the ratio of the Gross enrolment ratio (%) of Suriname in 2007 to that in 2008?
Make the answer very short. 0.97. What is the ratio of the Gross enrolment ratio (%) of Azerbaijan in 2007 to that in 2009?
Provide a short and direct response. 0.98. What is the ratio of the Gross enrolment ratio (%) of Dominica in 2007 to that in 2009?
Provide a succinct answer. 1.02. What is the ratio of the Gross enrolment ratio (%) of Nigeria in 2007 to that in 2009?
Offer a terse response. 0.81. What is the ratio of the Gross enrolment ratio (%) of Azerbaijan in 2008 to that in 2009?
Offer a very short reply. 0.99. What is the ratio of the Gross enrolment ratio (%) in Nigeria in 2008 to that in 2009?
Your answer should be compact. 0.9. What is the ratio of the Gross enrolment ratio (%) of Suriname in 2008 to that in 2009?
Offer a terse response. 1.02. What is the difference between the highest and the second highest Gross enrolment ratio (%) in Azerbaijan?
Provide a succinct answer. 0.75. What is the difference between the highest and the second highest Gross enrolment ratio (%) of Dominica?
Provide a succinct answer. 1.51. What is the difference between the highest and the second highest Gross enrolment ratio (%) in Nigeria?
Your response must be concise. 3.81. What is the difference between the highest and the second highest Gross enrolment ratio (%) of Suriname?
Keep it short and to the point. 1.51. What is the difference between the highest and the lowest Gross enrolment ratio (%) of Azerbaijan?
Make the answer very short. 10.59. What is the difference between the highest and the lowest Gross enrolment ratio (%) in Dominica?
Make the answer very short. 34.39. What is the difference between the highest and the lowest Gross enrolment ratio (%) of Nigeria?
Offer a terse response. 14.31. What is the difference between the highest and the lowest Gross enrolment ratio (%) of Suriname?
Make the answer very short. 20.12. 